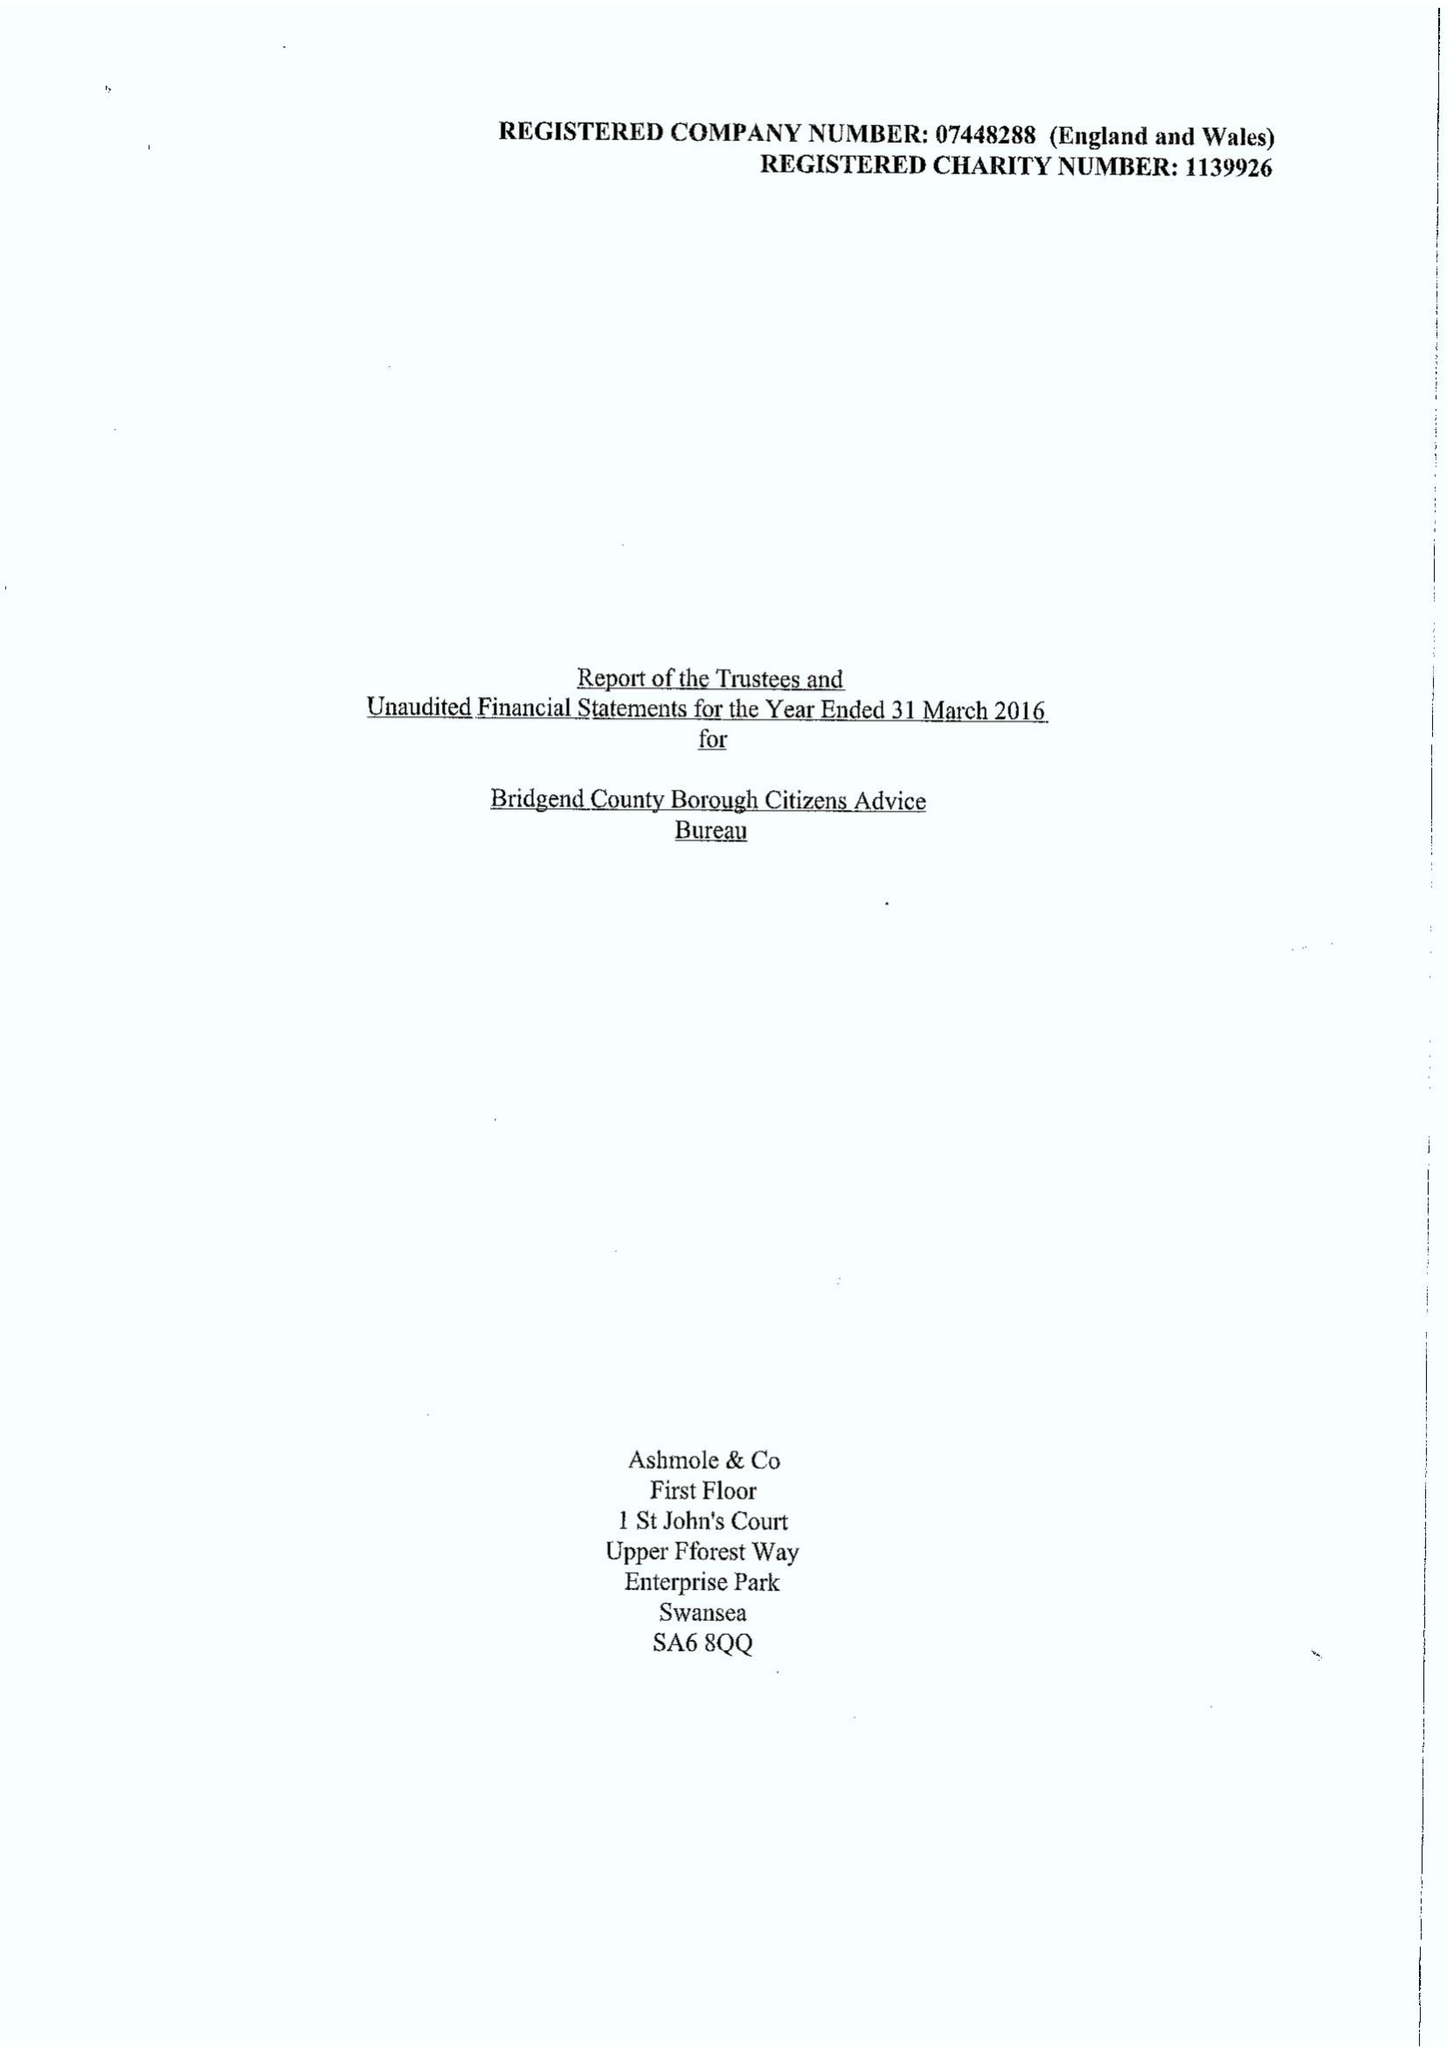What is the value for the charity_name?
Answer the question using a single word or phrase. Bridgend County Borough Citizens Advice Bureau 